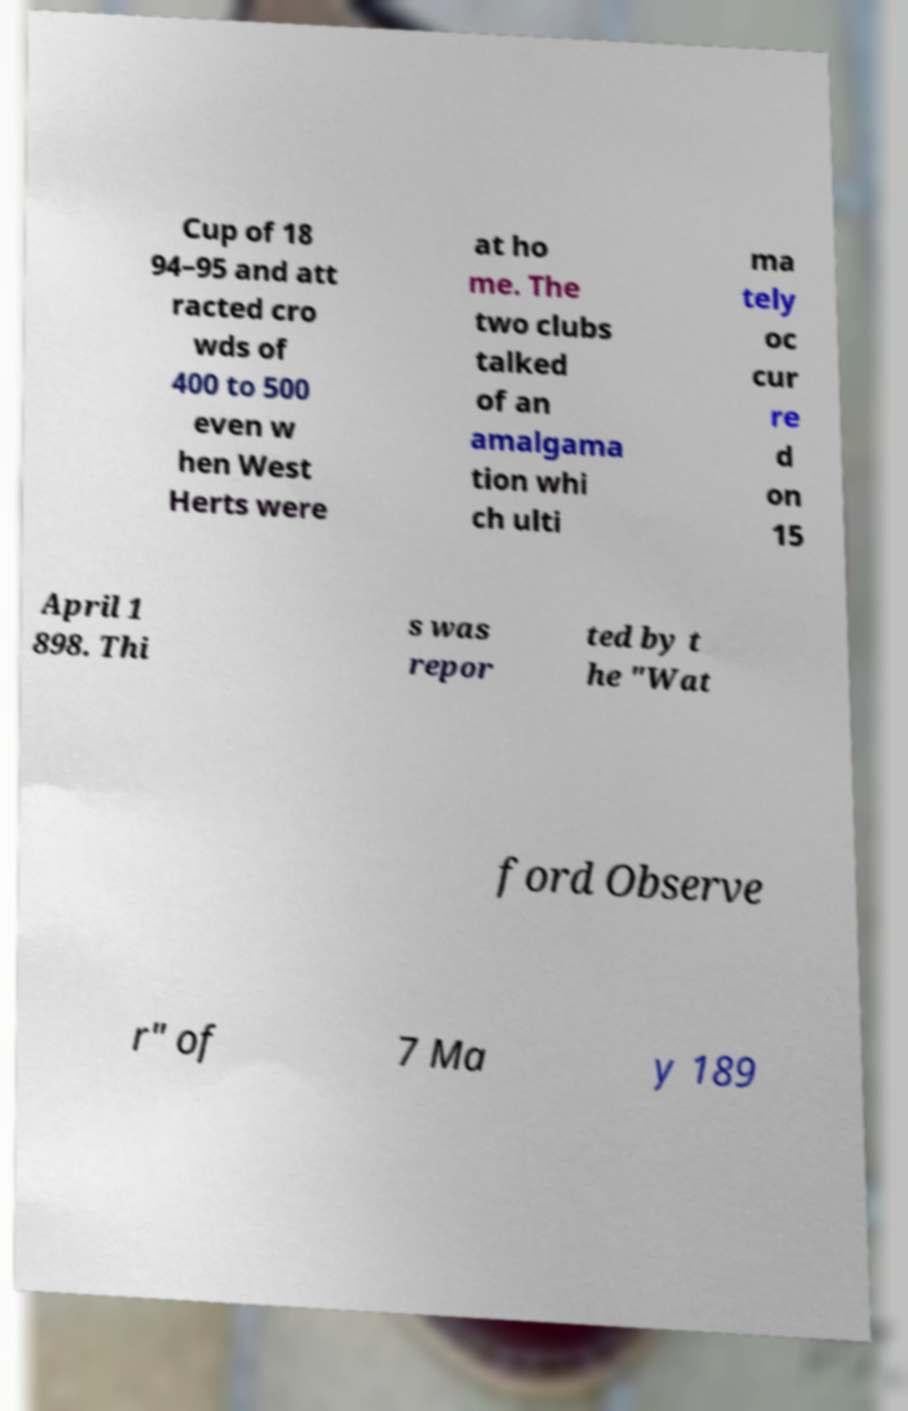Please read and relay the text visible in this image. What does it say? Cup of 18 94–95 and att racted cro wds of 400 to 500 even w hen West Herts were at ho me. The two clubs talked of an amalgama tion whi ch ulti ma tely oc cur re d on 15 April 1 898. Thi s was repor ted by t he "Wat ford Observe r" of 7 Ma y 189 